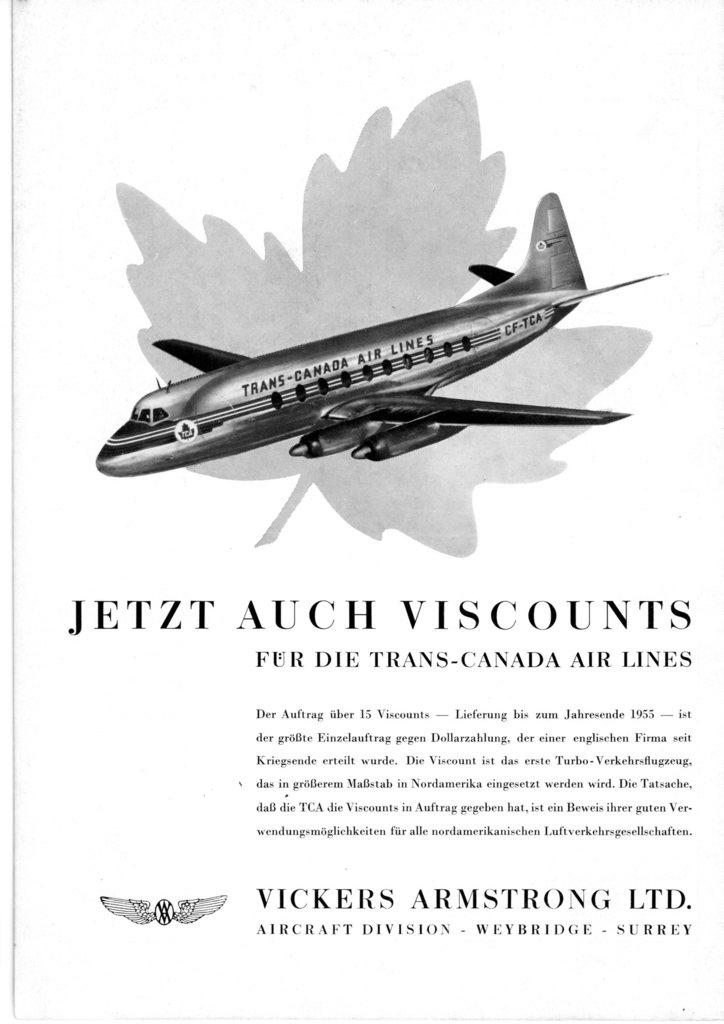How was the image altered or modified? The image is edited, which means it has been altered or modified. What else can be seen in the image besides the edited content? There is text written in the image. What is the main subject of the image? There is an image of an airplane in the image. Where is the dad sitting in the image? There is no dad present in the image; it only features an edited image with text and an airplane. What type of iron is visible in the image? There is no iron present in the image. 